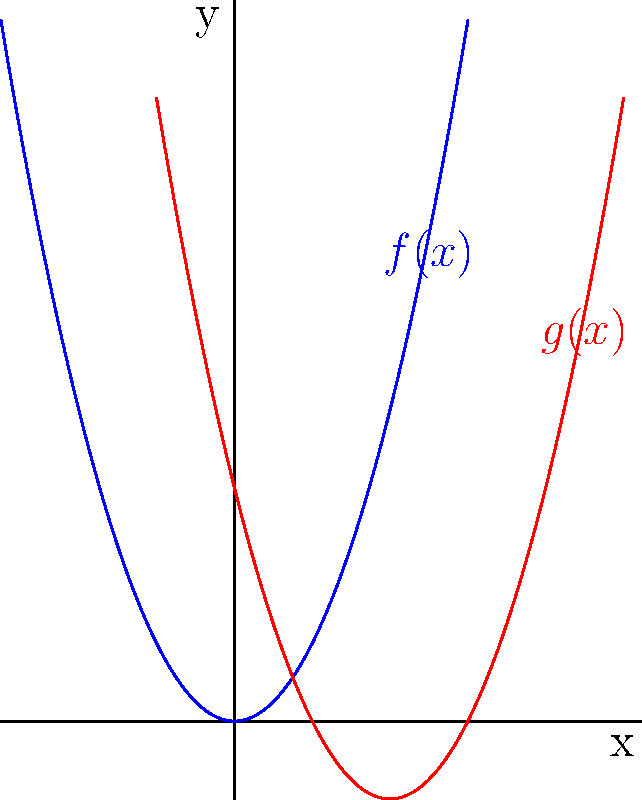As a copyright infringement protection expert, you're analyzing a case where a content creator's polynomial function graph has been potentially plagiarized. The original function $f(x)=x^2$ is shown in blue, and the suspected copy $g(x)$ is shown in red. How would you describe the transformation from $f(x)$ to $g(x)$ to prove that $g(x)$ is a modified version of $f(x)$? To prove that $g(x)$ is a modified version of $f(x)$, we need to identify the transformations applied:

1. Horizontal shift: The vertex of $g(x)$ is shifted 2 units to the right compared to $f(x)$. This suggests a transformation of $(x-2)$.

2. Vertical shift: The parabola of $g(x)$ is shifted 1 unit down compared to $f(x)$. This suggests a transformation of $-1$.

3. Combining these transformations:
   $g(x) = f(x-2) - 1$
   $g(x) = (x-2)^2 - 1$

4. To verify:
   - The vertex of $f(x)$ is at (0,0)
   - The vertex of $g(x)$ is at (2,-1)

These transformations prove that $g(x)$ is indeed a modified version of $f(x)$, demonstrating a clear relationship between the original and the suspected copy.
Answer: $g(x) = (x-2)^2 - 1$: right shift by 2, down shift by 1 